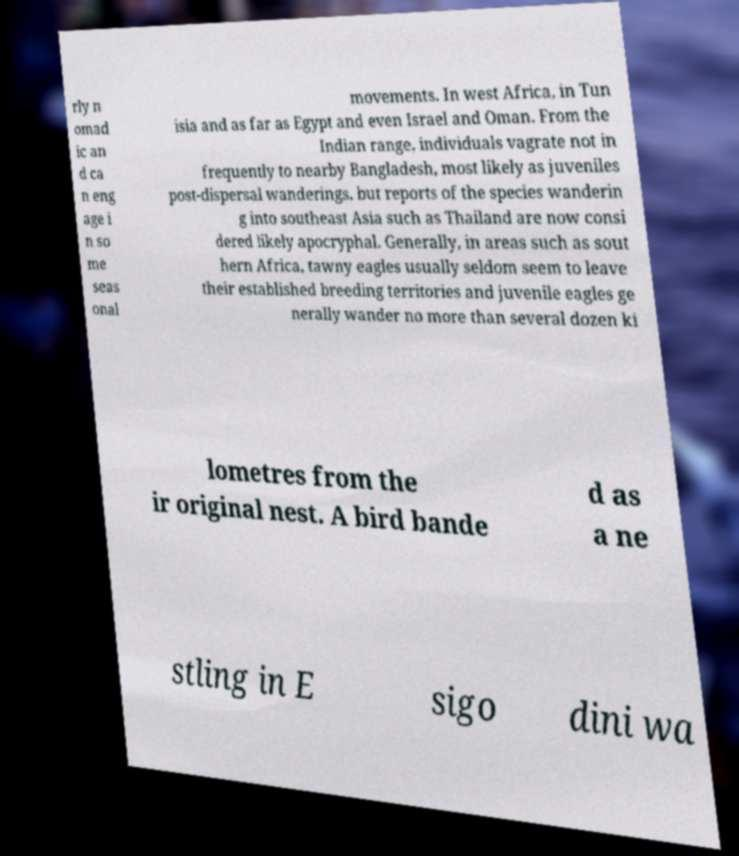I need the written content from this picture converted into text. Can you do that? rly n omad ic an d ca n eng age i n so me seas onal movements. In west Africa, in Tun isia and as far as Egypt and even Israel and Oman. From the Indian range, individuals vagrate not in frequently to nearby Bangladesh, most likely as juveniles post-dispersal wanderings, but reports of the species wanderin g into southeast Asia such as Thailand are now consi dered likely apocryphal. Generally, in areas such as sout hern Africa, tawny eagles usually seldom seem to leave their established breeding territories and juvenile eagles ge nerally wander no more than several dozen ki lometres from the ir original nest. A bird bande d as a ne stling in E sigo dini wa 